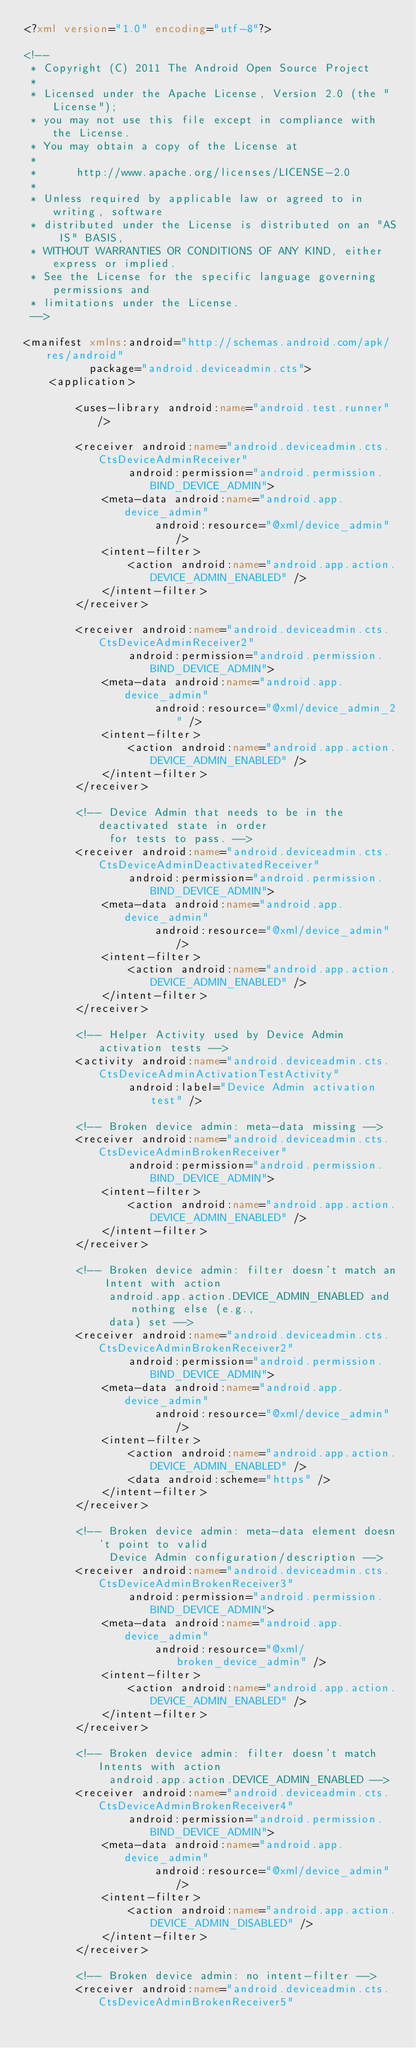Convert code to text. <code><loc_0><loc_0><loc_500><loc_500><_XML_><?xml version="1.0" encoding="utf-8"?>

<!--
 * Copyright (C) 2011 The Android Open Source Project
 *
 * Licensed under the Apache License, Version 2.0 (the "License");
 * you may not use this file except in compliance with the License.
 * You may obtain a copy of the License at
 *
 *      http://www.apache.org/licenses/LICENSE-2.0
 *
 * Unless required by applicable law or agreed to in writing, software
 * distributed under the License is distributed on an "AS IS" BASIS,
 * WITHOUT WARRANTIES OR CONDITIONS OF ANY KIND, either express or implied.
 * See the License for the specific language governing permissions and
 * limitations under the License.
 -->

<manifest xmlns:android="http://schemas.android.com/apk/res/android"
          package="android.deviceadmin.cts">
    <application>

        <uses-library android:name="android.test.runner"/>

        <receiver android:name="android.deviceadmin.cts.CtsDeviceAdminReceiver"
                android:permission="android.permission.BIND_DEVICE_ADMIN">
            <meta-data android:name="android.app.device_admin"
                    android:resource="@xml/device_admin" />
            <intent-filter>
                <action android:name="android.app.action.DEVICE_ADMIN_ENABLED" />
            </intent-filter>
        </receiver>
        
        <receiver android:name="android.deviceadmin.cts.CtsDeviceAdminReceiver2"
                android:permission="android.permission.BIND_DEVICE_ADMIN">
            <meta-data android:name="android.app.device_admin"
                    android:resource="@xml/device_admin_2" />
            <intent-filter>
                <action android:name="android.app.action.DEVICE_ADMIN_ENABLED" />
            </intent-filter>
        </receiver>

        <!-- Device Admin that needs to be in the deactivated state in order
             for tests to pass. -->
        <receiver android:name="android.deviceadmin.cts.CtsDeviceAdminDeactivatedReceiver"
                android:permission="android.permission.BIND_DEVICE_ADMIN">
            <meta-data android:name="android.app.device_admin"
                    android:resource="@xml/device_admin" />
            <intent-filter>
                <action android:name="android.app.action.DEVICE_ADMIN_ENABLED" />
            </intent-filter>
        </receiver>

        <!-- Helper Activity used by Device Admin activation tests -->
        <activity android:name="android.deviceadmin.cts.CtsDeviceAdminActivationTestActivity"
                android:label="Device Admin activation test" />

        <!-- Broken device admin: meta-data missing -->
        <receiver android:name="android.deviceadmin.cts.CtsDeviceAdminBrokenReceiver"
                android:permission="android.permission.BIND_DEVICE_ADMIN">
            <intent-filter>
                <action android:name="android.app.action.DEVICE_ADMIN_ENABLED" />
            </intent-filter>
        </receiver>

        <!-- Broken device admin: filter doesn't match an Intent with action
             android.app.action.DEVICE_ADMIN_ENABLED and nothing else (e.g.,
             data) set -->
        <receiver android:name="android.deviceadmin.cts.CtsDeviceAdminBrokenReceiver2"
                android:permission="android.permission.BIND_DEVICE_ADMIN">
            <meta-data android:name="android.app.device_admin"
                    android:resource="@xml/device_admin" />
            <intent-filter>
                <action android:name="android.app.action.DEVICE_ADMIN_ENABLED" />
                <data android:scheme="https" />
            </intent-filter>
        </receiver>

        <!-- Broken device admin: meta-data element doesn't point to valid
             Device Admin configuration/description -->
        <receiver android:name="android.deviceadmin.cts.CtsDeviceAdminBrokenReceiver3"
                android:permission="android.permission.BIND_DEVICE_ADMIN">
            <meta-data android:name="android.app.device_admin"
                    android:resource="@xml/broken_device_admin" />
            <intent-filter>
                <action android:name="android.app.action.DEVICE_ADMIN_ENABLED" />
            </intent-filter>
        </receiver>

        <!-- Broken device admin: filter doesn't match Intents with action
             android.app.action.DEVICE_ADMIN_ENABLED -->
        <receiver android:name="android.deviceadmin.cts.CtsDeviceAdminBrokenReceiver4"
                android:permission="android.permission.BIND_DEVICE_ADMIN">
            <meta-data android:name="android.app.device_admin"
                    android:resource="@xml/device_admin" />
            <intent-filter>
                <action android:name="android.app.action.DEVICE_ADMIN_DISABLED" />
            </intent-filter>
        </receiver>

        <!-- Broken device admin: no intent-filter -->
        <receiver android:name="android.deviceadmin.cts.CtsDeviceAdminBrokenReceiver5"</code> 